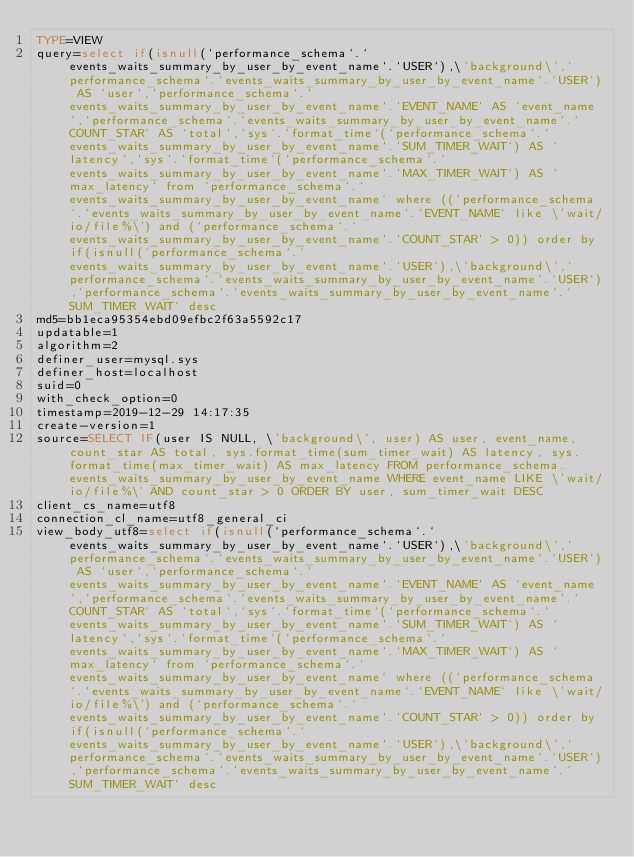<code> <loc_0><loc_0><loc_500><loc_500><_VisualBasic_>TYPE=VIEW
query=select if(isnull(`performance_schema`.`events_waits_summary_by_user_by_event_name`.`USER`),\'background\',`performance_schema`.`events_waits_summary_by_user_by_event_name`.`USER`) AS `user`,`performance_schema`.`events_waits_summary_by_user_by_event_name`.`EVENT_NAME` AS `event_name`,`performance_schema`.`events_waits_summary_by_user_by_event_name`.`COUNT_STAR` AS `total`,`sys`.`format_time`(`performance_schema`.`events_waits_summary_by_user_by_event_name`.`SUM_TIMER_WAIT`) AS `latency`,`sys`.`format_time`(`performance_schema`.`events_waits_summary_by_user_by_event_name`.`MAX_TIMER_WAIT`) AS `max_latency` from `performance_schema`.`events_waits_summary_by_user_by_event_name` where ((`performance_schema`.`events_waits_summary_by_user_by_event_name`.`EVENT_NAME` like \'wait/io/file%\') and (`performance_schema`.`events_waits_summary_by_user_by_event_name`.`COUNT_STAR` > 0)) order by if(isnull(`performance_schema`.`events_waits_summary_by_user_by_event_name`.`USER`),\'background\',`performance_schema`.`events_waits_summary_by_user_by_event_name`.`USER`),`performance_schema`.`events_waits_summary_by_user_by_event_name`.`SUM_TIMER_WAIT` desc
md5=bb1eca95354ebd09efbc2f63a5592c17
updatable=1
algorithm=2
definer_user=mysql.sys
definer_host=localhost
suid=0
with_check_option=0
timestamp=2019-12-29 14:17:35
create-version=1
source=SELECT IF(user IS NULL, \'background\', user) AS user, event_name, count_star AS total, sys.format_time(sum_timer_wait) AS latency, sys.format_time(max_timer_wait) AS max_latency FROM performance_schema.events_waits_summary_by_user_by_event_name WHERE event_name LIKE \'wait/io/file%\' AND count_star > 0 ORDER BY user, sum_timer_wait DESC
client_cs_name=utf8
connection_cl_name=utf8_general_ci
view_body_utf8=select if(isnull(`performance_schema`.`events_waits_summary_by_user_by_event_name`.`USER`),\'background\',`performance_schema`.`events_waits_summary_by_user_by_event_name`.`USER`) AS `user`,`performance_schema`.`events_waits_summary_by_user_by_event_name`.`EVENT_NAME` AS `event_name`,`performance_schema`.`events_waits_summary_by_user_by_event_name`.`COUNT_STAR` AS `total`,`sys`.`format_time`(`performance_schema`.`events_waits_summary_by_user_by_event_name`.`SUM_TIMER_WAIT`) AS `latency`,`sys`.`format_time`(`performance_schema`.`events_waits_summary_by_user_by_event_name`.`MAX_TIMER_WAIT`) AS `max_latency` from `performance_schema`.`events_waits_summary_by_user_by_event_name` where ((`performance_schema`.`events_waits_summary_by_user_by_event_name`.`EVENT_NAME` like \'wait/io/file%\') and (`performance_schema`.`events_waits_summary_by_user_by_event_name`.`COUNT_STAR` > 0)) order by if(isnull(`performance_schema`.`events_waits_summary_by_user_by_event_name`.`USER`),\'background\',`performance_schema`.`events_waits_summary_by_user_by_event_name`.`USER`),`performance_schema`.`events_waits_summary_by_user_by_event_name`.`SUM_TIMER_WAIT` desc
</code> 